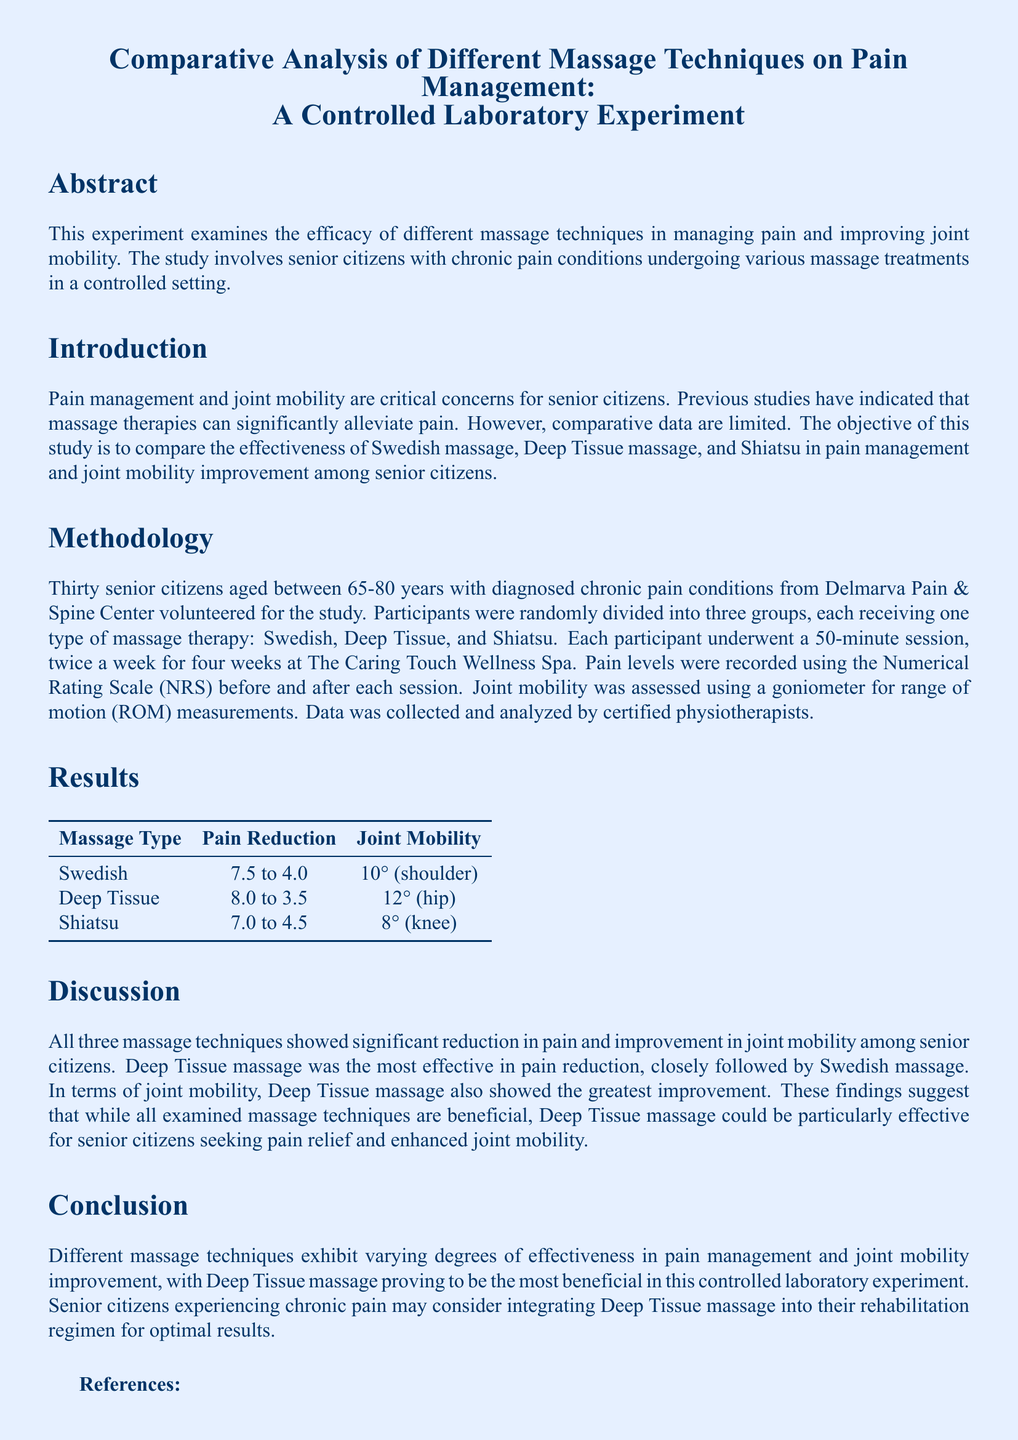What was the average age of participants? The average age of participants is mentioned as being between 65-80 years in the document.
Answer: 65-80 years Which massage technique showed the highest pain reduction? The results indicate that Deep Tissue massage showed the highest pain reduction from 8.0 to 3.5.
Answer: Deep Tissue What is the range of motion improvement for Swedish massage? The document states that Swedish massage resulted in a 10° improvement in shoulder joint mobility.
Answer: 10° What was the pain level before Swedish massage? The pain level before Swedish massage was recorded as 7.5 on the Numerical Rating Scale.
Answer: 7.5 How many sessions did each participant undergo? The methodology detailed that each participant underwent 16 sessions over four weeks (twice a week).
Answer: 16 sessions Which massage technique was suggested as particularly effective? The conclusion suggests that Deep Tissue massage could be particularly effective for pain relief and joint mobility.
Answer: Deep Tissue massage What type of study was conducted? The document specifies that it was a controlled laboratory experiment.
Answer: Controlled laboratory experiment What tool was used to assess joint mobility? The methodology states that a goniometer was used for range of motion measurements.
Answer: Goniometer Who analyzed the collected data? The document mentions that data was analyzed by certified physiotherapists.
Answer: Certified physiotherapists 